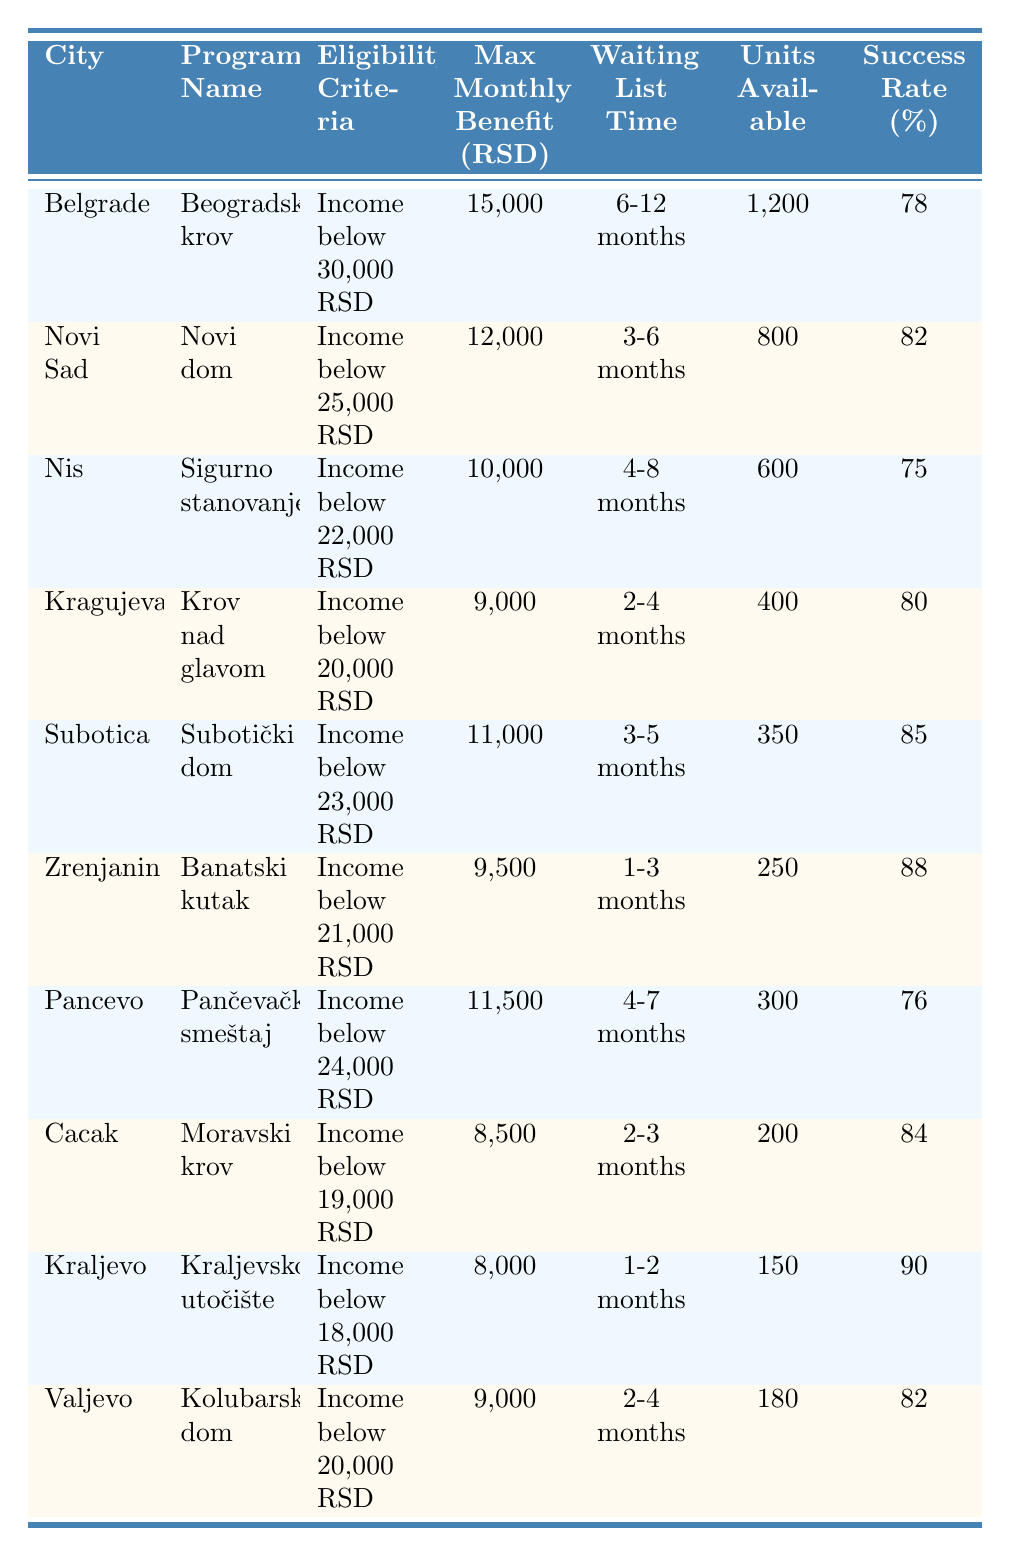What is the maximum monthly benefit offered by the program in Belgrade? The table shows that the maximum monthly benefit for the program "Beogradski krov" in Belgrade is listed under the "Max Monthly Benefit (RSD)" column, which states 15,000 RSD.
Answer: 15,000 RSD Which city has the shortest waiting list time for housing assistance? By examining the "Waiting List Time" column, Zrenjanin offers the shortest waiting time ranging from 1 to 3 months compared to other cities.
Answer: Zrenjanin What is the success rate of the program in Kraljevo? The "Success Rate (%)" for "Kraljevsko utočište" in Kraljevo is listed in the table as 90%.
Answer: 90% How many units are available for the program in Subotica? The table indicates that the program "Subotički dom" in Subotica has 350 units available under the "Units Available" column.
Answer: 350 If we consider the maximum monthly benefits of all programs, what is the average benefit across the listed cities? The maximum benefits are 15,000, 12,000, 10,000, 9,000, 11,000, 9,500, 11,500, 8,500, 8,000, and 9,000. Summing these values gives 94,000 and dividing by 10 cities results in an average of 9,400 RSD.
Answer: 9,400 RSD Is the success rate of programs in Novi Sad higher than that in Nis? Yes, the success rate for "Novi dom" in Novi Sad is 82%, while "Sigurno stanovanje" in Nis has a success rate of 75%. Hence, Novi Sad has a higher success rate.
Answer: Yes Which city has the highest maximum monthly benefit and what is that amount? The maximum monthly benefit is 15,000 RSD from the program "Beogradski krov" in Belgrade. Checking the "Max Monthly Benefit (RSD)" column, it's confirmed as the highest among the listed cities.
Answer: Belgrade, 15,000 RSD What is the difference in waiting list time between the programs in Kragujevac and Cacak? Kragujevac has a waiting list time of 2-4 months, while Cacak has 2-3 months. The difference in maximum waiting time (4 - 3 months) results in a 1-month difference.
Answer: 1 month How many more units are available in Belgrade compared to Zrenjanin? Belgrade has 1,200 units and Zrenjanin has 250 units available. The difference is calculated as 1,200 - 250 = 950 units.
Answer: 950 units Is the eligibility income criteria more lenient in Subotica than in Valjevo? Yes, Subotica's eligibility income limit is 23,000 RSD while Valjevo's is 20,000 RSD, making it more lenient.
Answer: Yes 